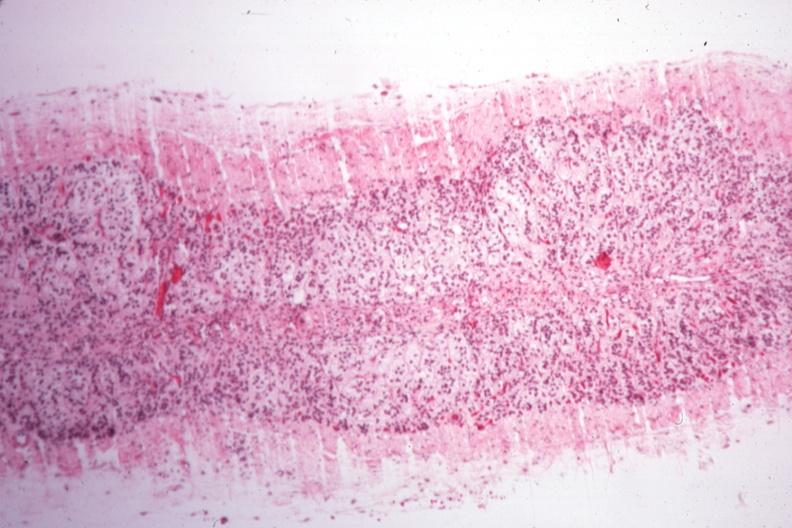where is this part in the figure?
Answer the question using a single word or phrase. Endocrine system 